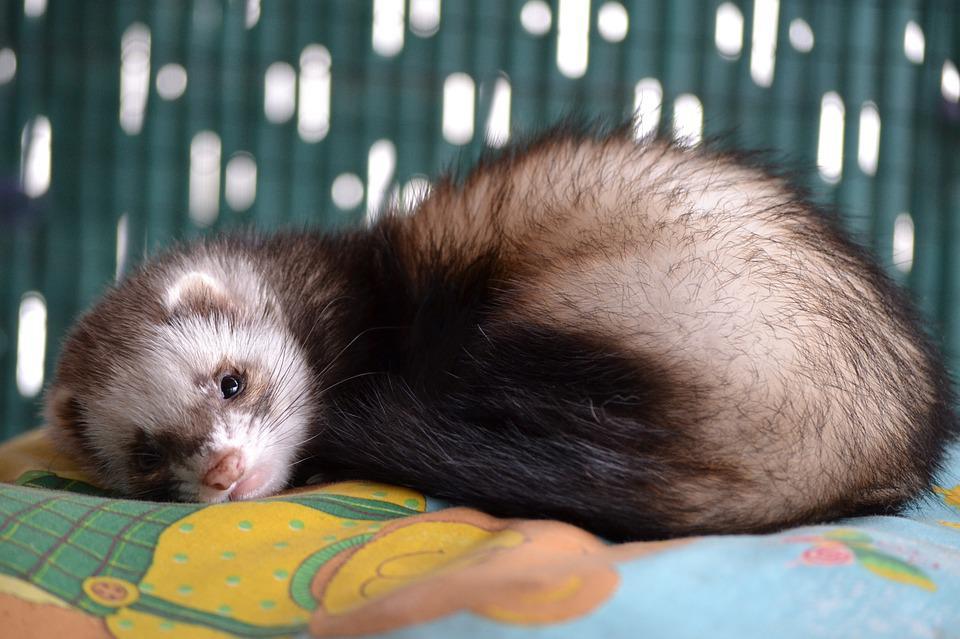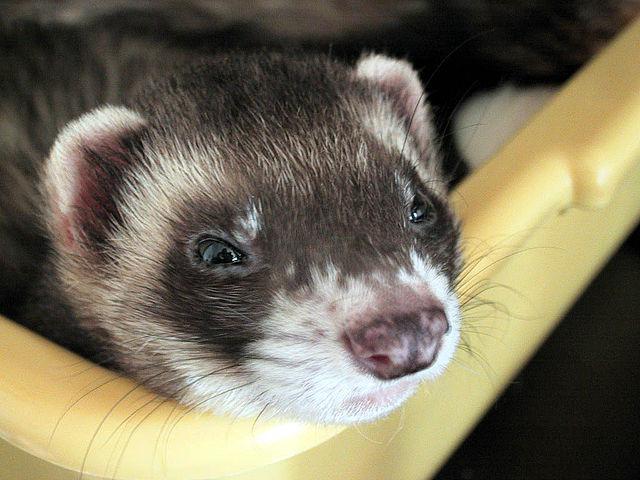The first image is the image on the left, the second image is the image on the right. Examine the images to the left and right. Is the description "The right image shows just one ferret, and it has a mottled brown nose." accurate? Answer yes or no. Yes. 